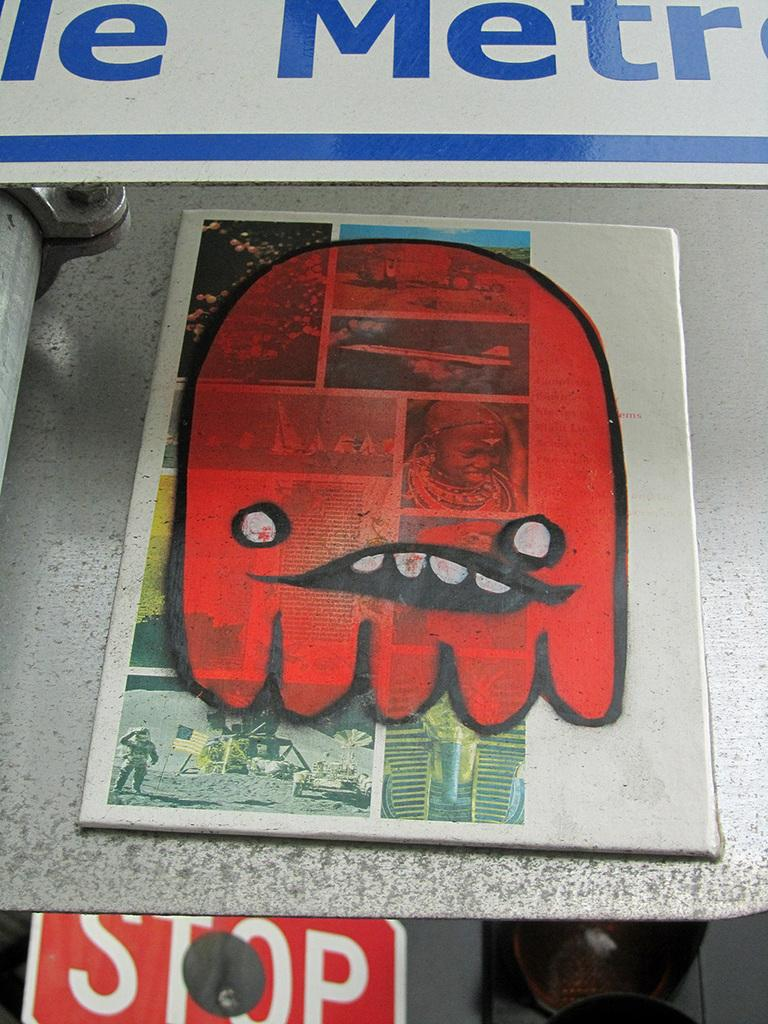<image>
Summarize the visual content of the image. A red drawing of a cartoon posted on a sign in front of a stop sign. 